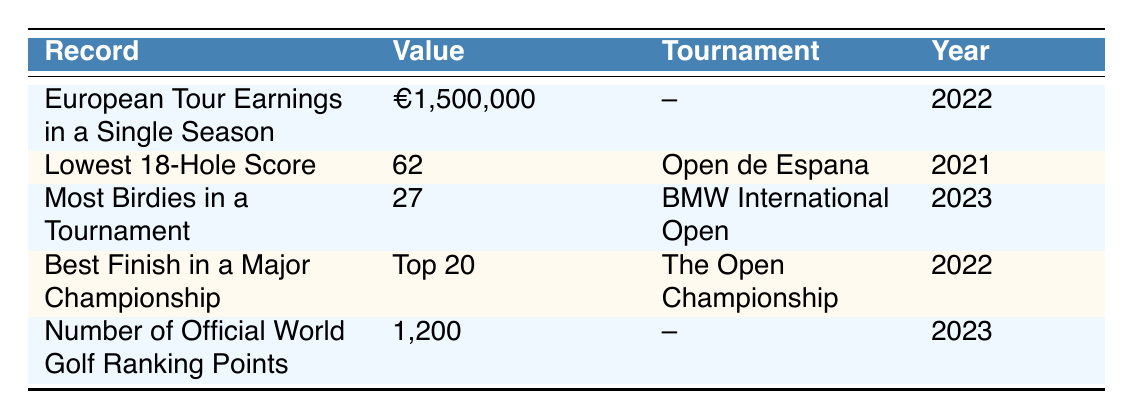What was Yannik Paul's European Tour earnings in 2022? The table specifically lists the record for European Tour earnings, which states the value is €1,500,000 in the year 2022.
Answer: €1,500,000 In what tournament did Yannik Paul record his lowest 18-hole score? The table specifies that Yannik Paul's lowest 18-hole score of 62 was recorded at the Open de Espana in the year 2021.
Answer: Open de Espana Did Yannik Paul achieve a top 20 finish in a major championship? The table indicates that he achieved his best finish in a major championship, which was a Top 20 finish at The Open Championship in 2022.
Answer: Yes What is the value of the most birdies recorded by Yannik Paul in a tournament? According to the table, the most birdies recorded by Yannik Paul in a tournament is 27 during the BMW International Open in 2023.
Answer: 27 What is the difference in Yannik Paul's European Tour earnings between 2022 and his official World Golf Ranking points in 2023? The European Tour earnings in 2022 are €1,500,000 and the official World Golf Ranking points in 2023 is 1,200. Since these values are in different units (monetary vs. points), we can state that both figures are significant in their respective contexts but cannot mathematically calculate a difference as they represent different measurements.
Answer: Cannot compute a difference In which year did Yannik Paul score the most birdies in a tournament? The table shows that Yannik Paul scored the most birdies, a total of 27, in the tournament held in 2023.
Answer: 2023 How many records are listed for Yannik Paul in this table? The table features a total of five specific records set by Yannik Paul throughout different years and tournaments.
Answer: 5 What was Yannik Paul's best finish in a major championship and in which year? According to the table, Yannik Paul's best finish in a major championship was Top 20 and this occurred in the year 2022 at The Open Championship.
Answer: Top 20 in 2022 Did Yannik Paul earn more than €1,000,000 in European Tour earnings in 2022? The table shows that Yannik Paul earned €1,500,000 in European Tour earnings in 2022, which is indeed more than €1,000,000.
Answer: Yes 